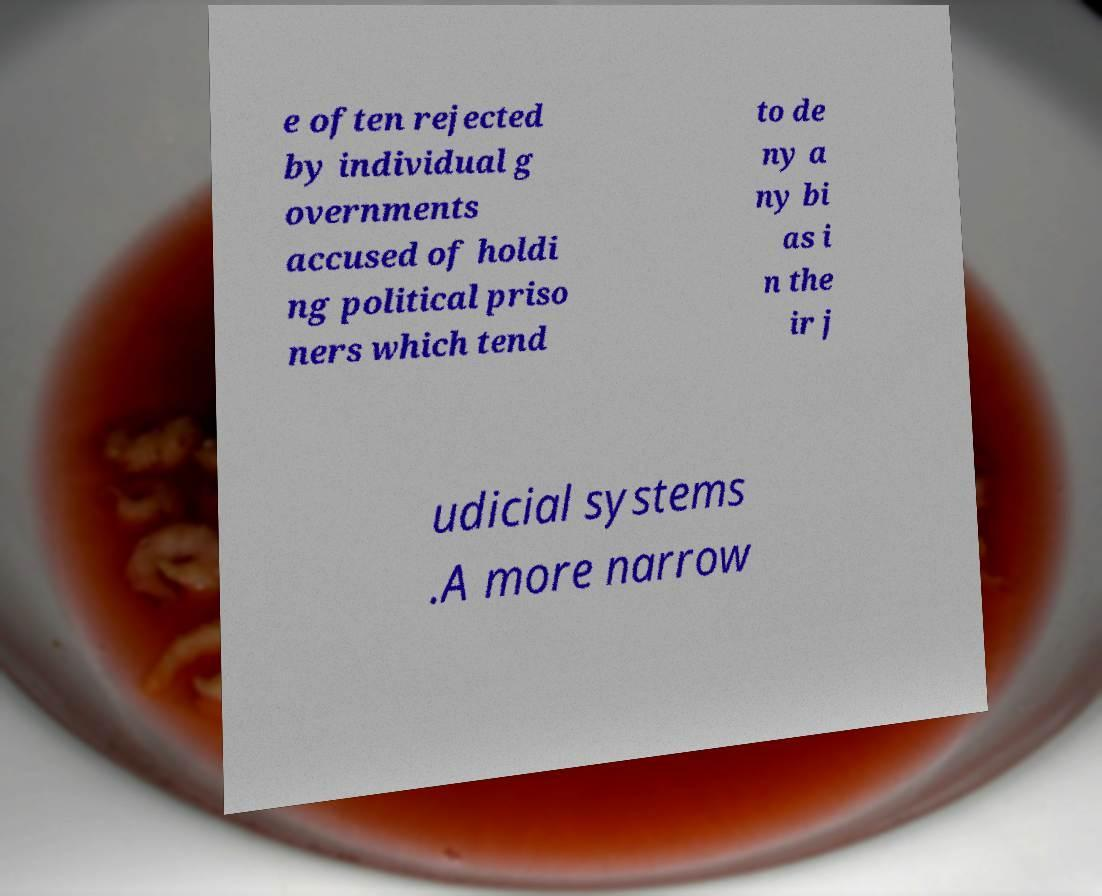I need the written content from this picture converted into text. Can you do that? e often rejected by individual g overnments accused of holdi ng political priso ners which tend to de ny a ny bi as i n the ir j udicial systems .A more narrow 